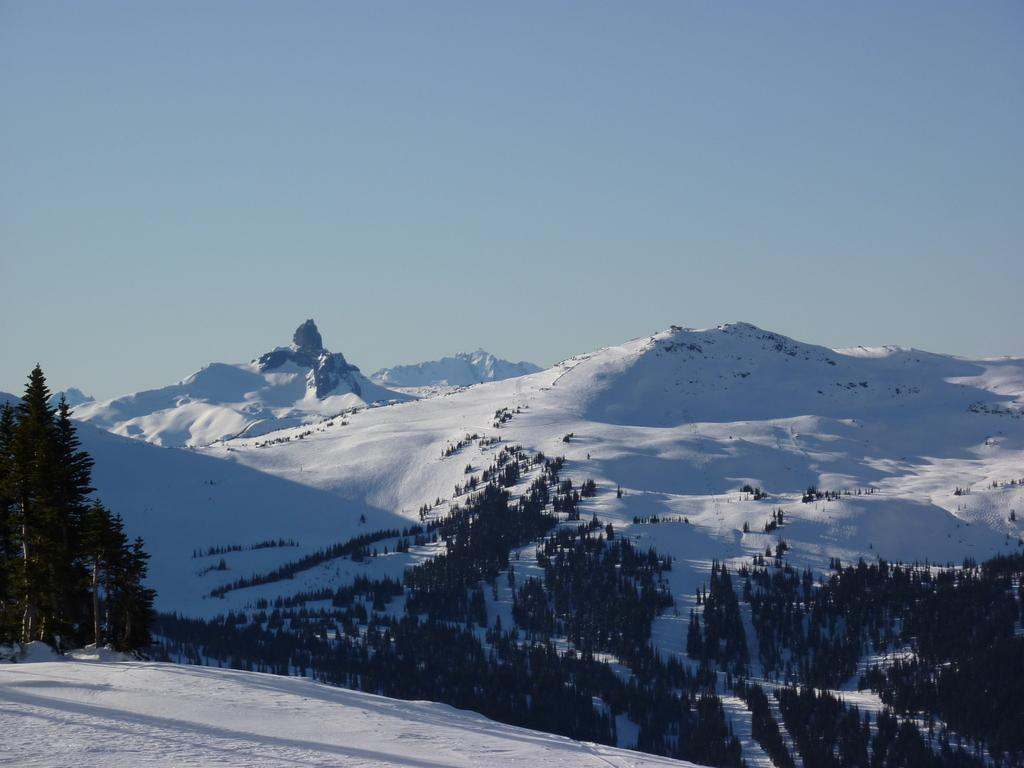What is the primary feature of the landscape in the image? The primary feature of the landscape in the image is mountain ranges covered with snow. Are there any other natural elements present on the mountains in the image? Yes, there are trees on the mountains in the image. What type of coast can be seen along the mountain range in the image? There is no coast visible in the image, as it features mountain ranges covered with snow and trees. 